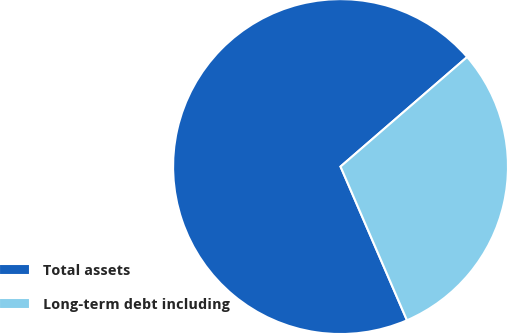Convert chart to OTSL. <chart><loc_0><loc_0><loc_500><loc_500><pie_chart><fcel>Total assets<fcel>Long-term debt including<nl><fcel>70.14%<fcel>29.86%<nl></chart> 